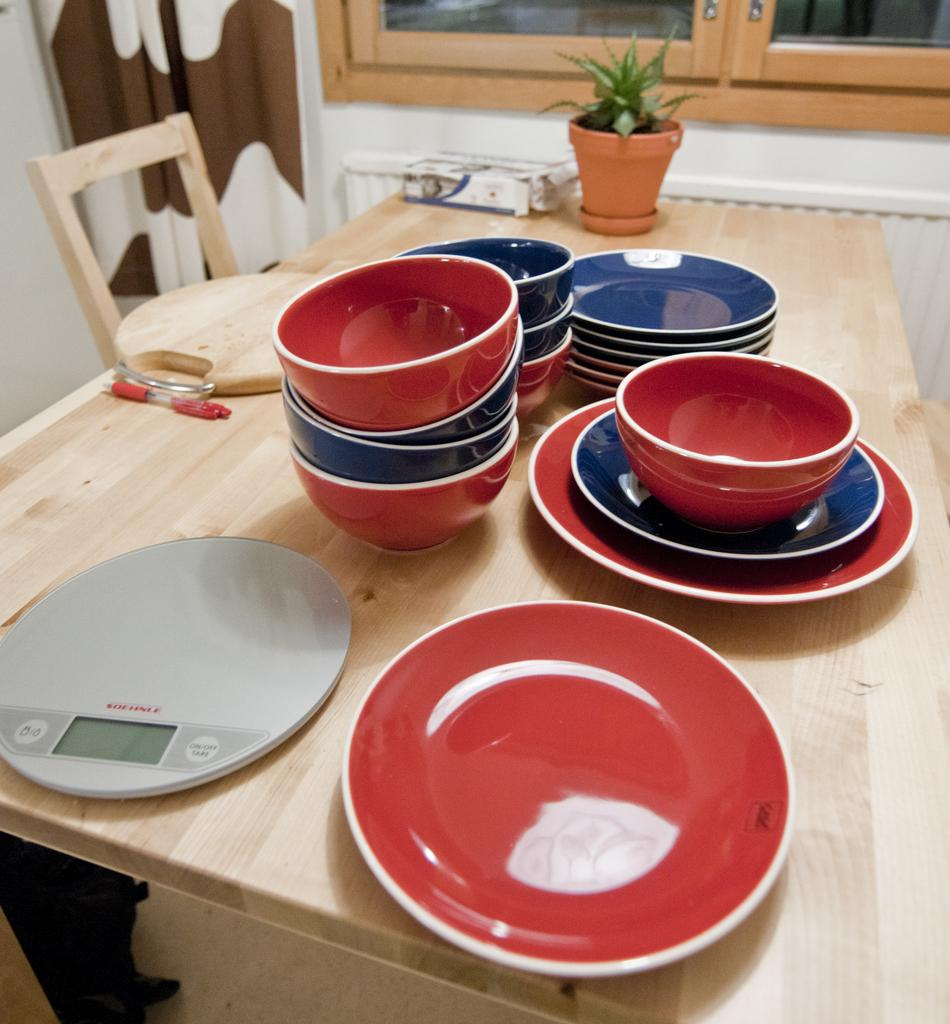Provide a one-sentence caption for the provided image. The button on the right side of the scale is to turn it on. 